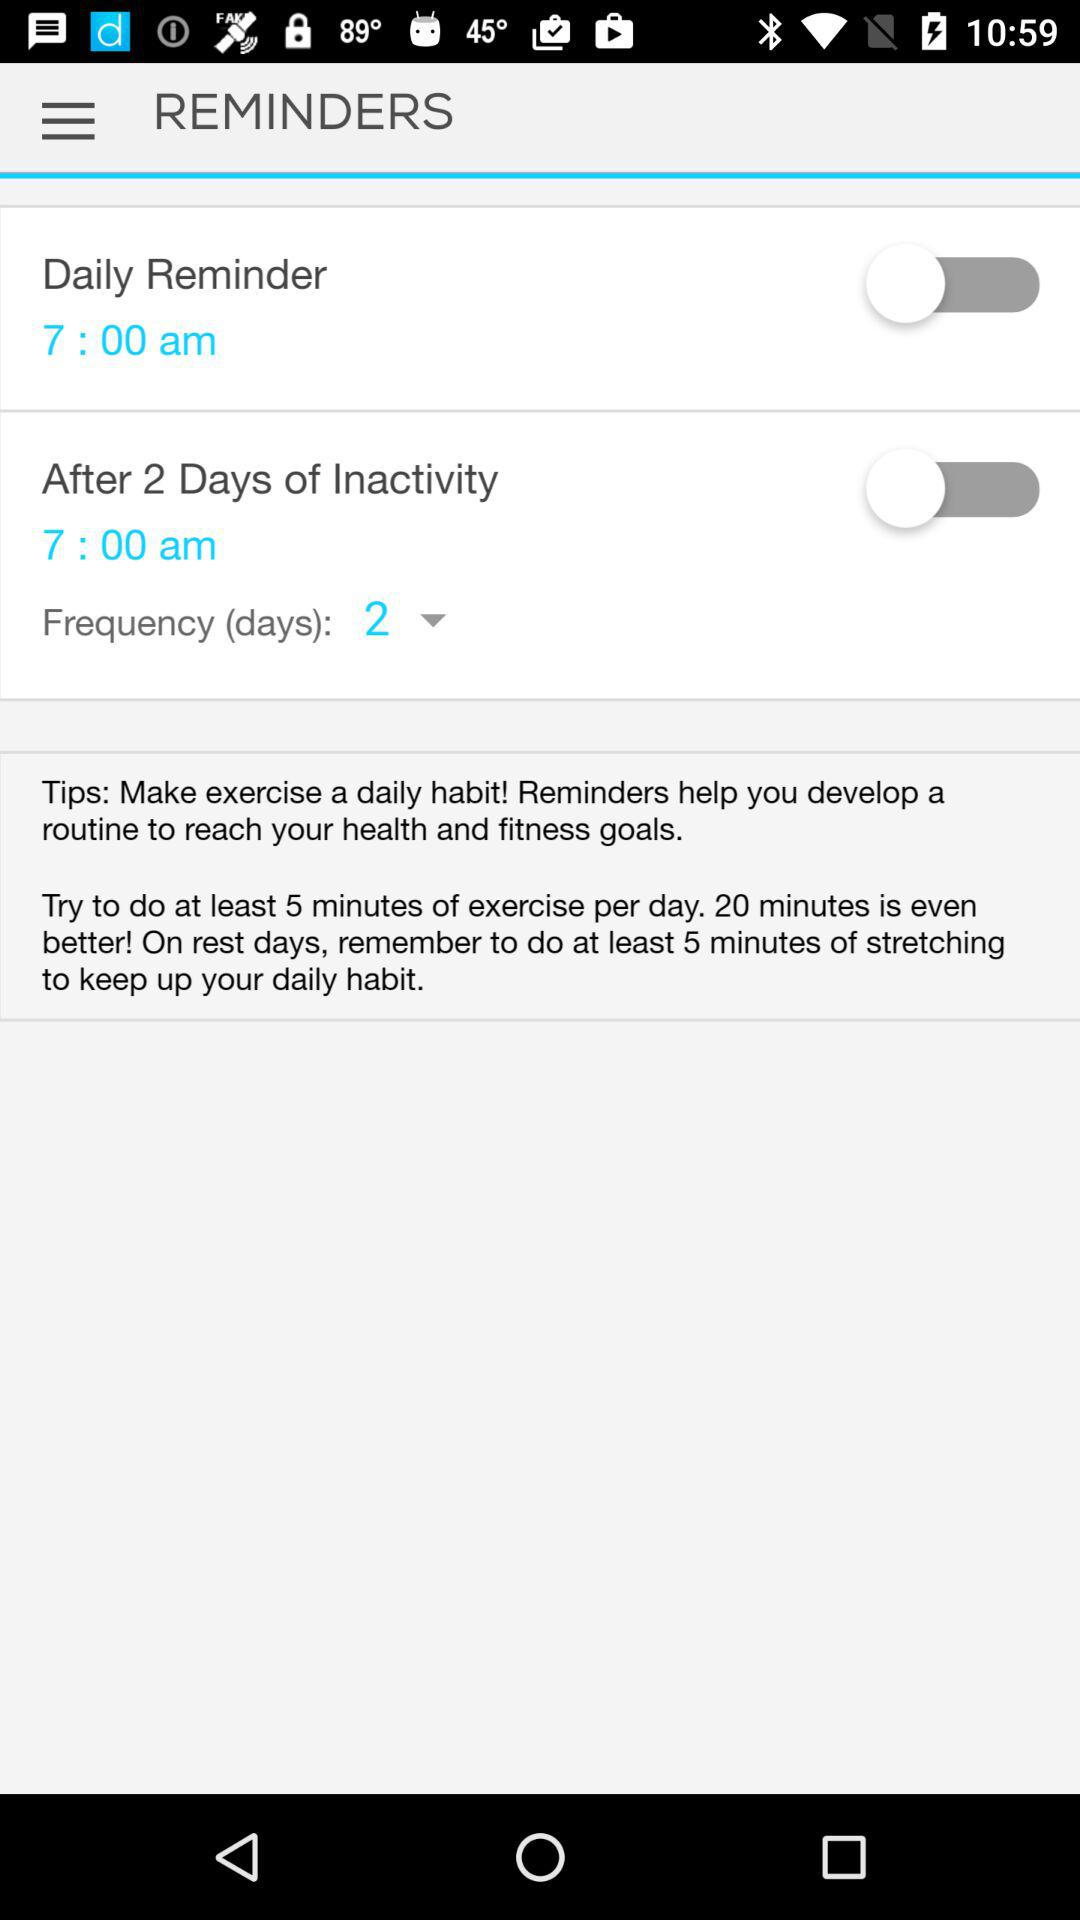What is the frequency in days? The frequency in days is 2. 